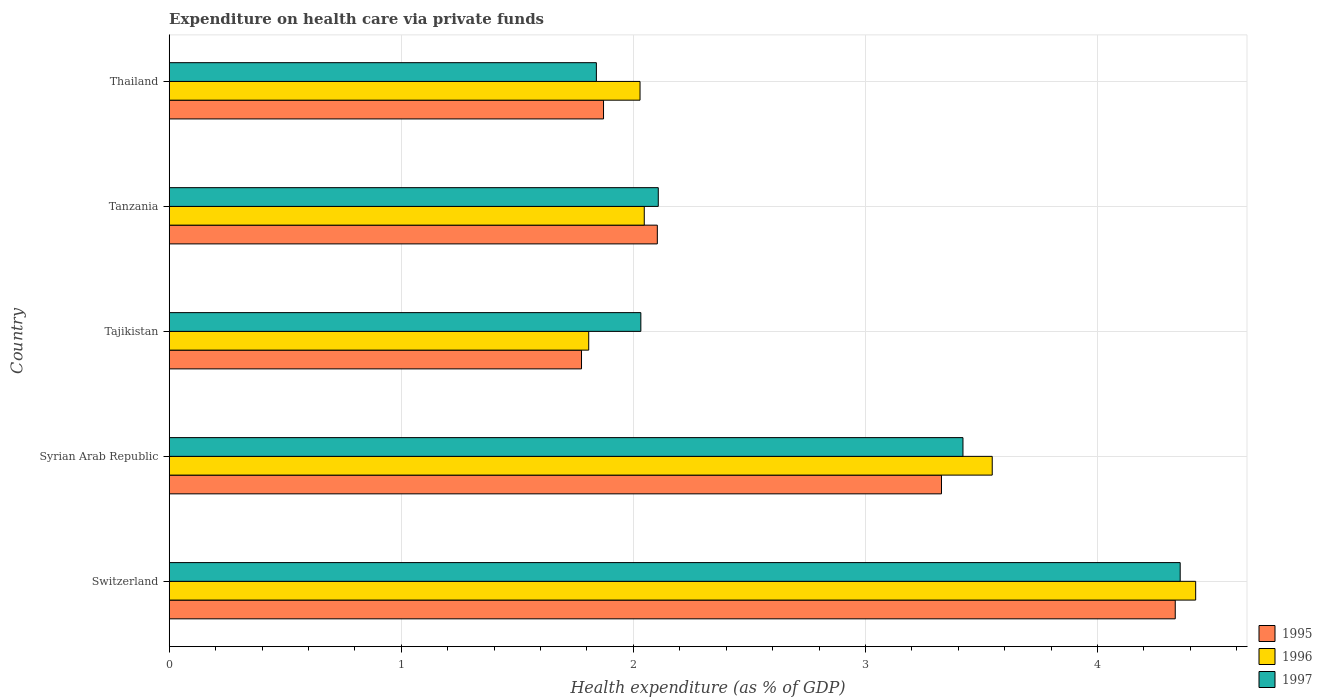How many different coloured bars are there?
Your response must be concise. 3. How many groups of bars are there?
Your answer should be compact. 5. Are the number of bars per tick equal to the number of legend labels?
Provide a succinct answer. Yes. How many bars are there on the 1st tick from the bottom?
Your answer should be very brief. 3. What is the label of the 5th group of bars from the top?
Keep it short and to the point. Switzerland. In how many cases, is the number of bars for a given country not equal to the number of legend labels?
Your answer should be very brief. 0. What is the expenditure made on health care in 1997 in Tanzania?
Make the answer very short. 2.11. Across all countries, what is the maximum expenditure made on health care in 1995?
Your answer should be compact. 4.33. Across all countries, what is the minimum expenditure made on health care in 1995?
Keep it short and to the point. 1.78. In which country was the expenditure made on health care in 1996 maximum?
Ensure brevity in your answer.  Switzerland. In which country was the expenditure made on health care in 1996 minimum?
Provide a short and direct response. Tajikistan. What is the total expenditure made on health care in 1995 in the graph?
Provide a succinct answer. 13.41. What is the difference between the expenditure made on health care in 1996 in Tajikistan and that in Tanzania?
Offer a very short reply. -0.24. What is the difference between the expenditure made on health care in 1995 in Syrian Arab Republic and the expenditure made on health care in 1997 in Tajikistan?
Ensure brevity in your answer.  1.3. What is the average expenditure made on health care in 1996 per country?
Give a very brief answer. 2.77. What is the difference between the expenditure made on health care in 1995 and expenditure made on health care in 1996 in Switzerland?
Your answer should be compact. -0.09. In how many countries, is the expenditure made on health care in 1997 greater than 4.4 %?
Your response must be concise. 0. What is the ratio of the expenditure made on health care in 1996 in Switzerland to that in Thailand?
Offer a terse response. 2.18. What is the difference between the highest and the second highest expenditure made on health care in 1997?
Ensure brevity in your answer.  0.94. What is the difference between the highest and the lowest expenditure made on health care in 1995?
Keep it short and to the point. 2.56. Is it the case that in every country, the sum of the expenditure made on health care in 1995 and expenditure made on health care in 1997 is greater than the expenditure made on health care in 1996?
Your answer should be compact. Yes. What is the difference between two consecutive major ticks on the X-axis?
Make the answer very short. 1. Are the values on the major ticks of X-axis written in scientific E-notation?
Ensure brevity in your answer.  No. How many legend labels are there?
Provide a succinct answer. 3. How are the legend labels stacked?
Provide a succinct answer. Vertical. What is the title of the graph?
Offer a terse response. Expenditure on health care via private funds. Does "2003" appear as one of the legend labels in the graph?
Give a very brief answer. No. What is the label or title of the X-axis?
Your response must be concise. Health expenditure (as % of GDP). What is the label or title of the Y-axis?
Provide a short and direct response. Country. What is the Health expenditure (as % of GDP) of 1995 in Switzerland?
Keep it short and to the point. 4.33. What is the Health expenditure (as % of GDP) in 1996 in Switzerland?
Provide a succinct answer. 4.42. What is the Health expenditure (as % of GDP) of 1997 in Switzerland?
Your response must be concise. 4.36. What is the Health expenditure (as % of GDP) of 1995 in Syrian Arab Republic?
Your answer should be compact. 3.33. What is the Health expenditure (as % of GDP) in 1996 in Syrian Arab Republic?
Make the answer very short. 3.55. What is the Health expenditure (as % of GDP) of 1997 in Syrian Arab Republic?
Offer a very short reply. 3.42. What is the Health expenditure (as % of GDP) in 1995 in Tajikistan?
Give a very brief answer. 1.78. What is the Health expenditure (as % of GDP) of 1996 in Tajikistan?
Your response must be concise. 1.81. What is the Health expenditure (as % of GDP) in 1997 in Tajikistan?
Provide a succinct answer. 2.03. What is the Health expenditure (as % of GDP) in 1995 in Tanzania?
Your answer should be compact. 2.1. What is the Health expenditure (as % of GDP) in 1996 in Tanzania?
Your response must be concise. 2.05. What is the Health expenditure (as % of GDP) in 1997 in Tanzania?
Make the answer very short. 2.11. What is the Health expenditure (as % of GDP) of 1995 in Thailand?
Give a very brief answer. 1.87. What is the Health expenditure (as % of GDP) of 1996 in Thailand?
Offer a very short reply. 2.03. What is the Health expenditure (as % of GDP) in 1997 in Thailand?
Your answer should be compact. 1.84. Across all countries, what is the maximum Health expenditure (as % of GDP) of 1995?
Provide a succinct answer. 4.33. Across all countries, what is the maximum Health expenditure (as % of GDP) of 1996?
Offer a terse response. 4.42. Across all countries, what is the maximum Health expenditure (as % of GDP) in 1997?
Your answer should be very brief. 4.36. Across all countries, what is the minimum Health expenditure (as % of GDP) of 1995?
Provide a short and direct response. 1.78. Across all countries, what is the minimum Health expenditure (as % of GDP) of 1996?
Keep it short and to the point. 1.81. Across all countries, what is the minimum Health expenditure (as % of GDP) in 1997?
Provide a succinct answer. 1.84. What is the total Health expenditure (as % of GDP) in 1995 in the graph?
Your answer should be compact. 13.41. What is the total Health expenditure (as % of GDP) in 1996 in the graph?
Offer a very short reply. 13.85. What is the total Health expenditure (as % of GDP) in 1997 in the graph?
Offer a very short reply. 13.76. What is the difference between the Health expenditure (as % of GDP) in 1996 in Switzerland and that in Syrian Arab Republic?
Keep it short and to the point. 0.88. What is the difference between the Health expenditure (as % of GDP) in 1997 in Switzerland and that in Syrian Arab Republic?
Offer a terse response. 0.94. What is the difference between the Health expenditure (as % of GDP) in 1995 in Switzerland and that in Tajikistan?
Keep it short and to the point. 2.56. What is the difference between the Health expenditure (as % of GDP) of 1996 in Switzerland and that in Tajikistan?
Provide a succinct answer. 2.62. What is the difference between the Health expenditure (as % of GDP) in 1997 in Switzerland and that in Tajikistan?
Your answer should be compact. 2.32. What is the difference between the Health expenditure (as % of GDP) in 1995 in Switzerland and that in Tanzania?
Your answer should be compact. 2.23. What is the difference between the Health expenditure (as % of GDP) in 1996 in Switzerland and that in Tanzania?
Give a very brief answer. 2.38. What is the difference between the Health expenditure (as % of GDP) in 1997 in Switzerland and that in Tanzania?
Offer a terse response. 2.25. What is the difference between the Health expenditure (as % of GDP) in 1995 in Switzerland and that in Thailand?
Ensure brevity in your answer.  2.46. What is the difference between the Health expenditure (as % of GDP) of 1996 in Switzerland and that in Thailand?
Make the answer very short. 2.39. What is the difference between the Health expenditure (as % of GDP) in 1997 in Switzerland and that in Thailand?
Your response must be concise. 2.52. What is the difference between the Health expenditure (as % of GDP) of 1995 in Syrian Arab Republic and that in Tajikistan?
Offer a very short reply. 1.55. What is the difference between the Health expenditure (as % of GDP) in 1996 in Syrian Arab Republic and that in Tajikistan?
Your response must be concise. 1.74. What is the difference between the Health expenditure (as % of GDP) of 1997 in Syrian Arab Republic and that in Tajikistan?
Make the answer very short. 1.39. What is the difference between the Health expenditure (as % of GDP) in 1995 in Syrian Arab Republic and that in Tanzania?
Your answer should be compact. 1.22. What is the difference between the Health expenditure (as % of GDP) of 1996 in Syrian Arab Republic and that in Tanzania?
Your response must be concise. 1.5. What is the difference between the Health expenditure (as % of GDP) in 1997 in Syrian Arab Republic and that in Tanzania?
Provide a succinct answer. 1.31. What is the difference between the Health expenditure (as % of GDP) of 1995 in Syrian Arab Republic and that in Thailand?
Keep it short and to the point. 1.46. What is the difference between the Health expenditure (as % of GDP) in 1996 in Syrian Arab Republic and that in Thailand?
Provide a short and direct response. 1.52. What is the difference between the Health expenditure (as % of GDP) in 1997 in Syrian Arab Republic and that in Thailand?
Provide a succinct answer. 1.58. What is the difference between the Health expenditure (as % of GDP) of 1995 in Tajikistan and that in Tanzania?
Offer a terse response. -0.33. What is the difference between the Health expenditure (as % of GDP) of 1996 in Tajikistan and that in Tanzania?
Provide a succinct answer. -0.24. What is the difference between the Health expenditure (as % of GDP) of 1997 in Tajikistan and that in Tanzania?
Offer a very short reply. -0.08. What is the difference between the Health expenditure (as % of GDP) in 1995 in Tajikistan and that in Thailand?
Give a very brief answer. -0.09. What is the difference between the Health expenditure (as % of GDP) in 1996 in Tajikistan and that in Thailand?
Give a very brief answer. -0.22. What is the difference between the Health expenditure (as % of GDP) in 1997 in Tajikistan and that in Thailand?
Make the answer very short. 0.19. What is the difference between the Health expenditure (as % of GDP) in 1995 in Tanzania and that in Thailand?
Ensure brevity in your answer.  0.23. What is the difference between the Health expenditure (as % of GDP) of 1996 in Tanzania and that in Thailand?
Give a very brief answer. 0.02. What is the difference between the Health expenditure (as % of GDP) of 1997 in Tanzania and that in Thailand?
Provide a short and direct response. 0.27. What is the difference between the Health expenditure (as % of GDP) in 1995 in Switzerland and the Health expenditure (as % of GDP) in 1996 in Syrian Arab Republic?
Provide a short and direct response. 0.79. What is the difference between the Health expenditure (as % of GDP) in 1995 in Switzerland and the Health expenditure (as % of GDP) in 1997 in Syrian Arab Republic?
Your response must be concise. 0.91. What is the difference between the Health expenditure (as % of GDP) in 1996 in Switzerland and the Health expenditure (as % of GDP) in 1997 in Syrian Arab Republic?
Your response must be concise. 1. What is the difference between the Health expenditure (as % of GDP) of 1995 in Switzerland and the Health expenditure (as % of GDP) of 1996 in Tajikistan?
Offer a very short reply. 2.53. What is the difference between the Health expenditure (as % of GDP) in 1995 in Switzerland and the Health expenditure (as % of GDP) in 1997 in Tajikistan?
Provide a succinct answer. 2.3. What is the difference between the Health expenditure (as % of GDP) of 1996 in Switzerland and the Health expenditure (as % of GDP) of 1997 in Tajikistan?
Your answer should be very brief. 2.39. What is the difference between the Health expenditure (as % of GDP) in 1995 in Switzerland and the Health expenditure (as % of GDP) in 1996 in Tanzania?
Make the answer very short. 2.29. What is the difference between the Health expenditure (as % of GDP) of 1995 in Switzerland and the Health expenditure (as % of GDP) of 1997 in Tanzania?
Give a very brief answer. 2.23. What is the difference between the Health expenditure (as % of GDP) in 1996 in Switzerland and the Health expenditure (as % of GDP) in 1997 in Tanzania?
Provide a short and direct response. 2.32. What is the difference between the Health expenditure (as % of GDP) in 1995 in Switzerland and the Health expenditure (as % of GDP) in 1996 in Thailand?
Keep it short and to the point. 2.31. What is the difference between the Health expenditure (as % of GDP) in 1995 in Switzerland and the Health expenditure (as % of GDP) in 1997 in Thailand?
Your answer should be compact. 2.49. What is the difference between the Health expenditure (as % of GDP) in 1996 in Switzerland and the Health expenditure (as % of GDP) in 1997 in Thailand?
Offer a terse response. 2.58. What is the difference between the Health expenditure (as % of GDP) in 1995 in Syrian Arab Republic and the Health expenditure (as % of GDP) in 1996 in Tajikistan?
Give a very brief answer. 1.52. What is the difference between the Health expenditure (as % of GDP) of 1995 in Syrian Arab Republic and the Health expenditure (as % of GDP) of 1997 in Tajikistan?
Make the answer very short. 1.3. What is the difference between the Health expenditure (as % of GDP) of 1996 in Syrian Arab Republic and the Health expenditure (as % of GDP) of 1997 in Tajikistan?
Offer a very short reply. 1.51. What is the difference between the Health expenditure (as % of GDP) of 1995 in Syrian Arab Republic and the Health expenditure (as % of GDP) of 1996 in Tanzania?
Provide a short and direct response. 1.28. What is the difference between the Health expenditure (as % of GDP) of 1995 in Syrian Arab Republic and the Health expenditure (as % of GDP) of 1997 in Tanzania?
Make the answer very short. 1.22. What is the difference between the Health expenditure (as % of GDP) in 1996 in Syrian Arab Republic and the Health expenditure (as % of GDP) in 1997 in Tanzania?
Your answer should be compact. 1.44. What is the difference between the Health expenditure (as % of GDP) in 1995 in Syrian Arab Republic and the Health expenditure (as % of GDP) in 1996 in Thailand?
Offer a very short reply. 1.3. What is the difference between the Health expenditure (as % of GDP) in 1995 in Syrian Arab Republic and the Health expenditure (as % of GDP) in 1997 in Thailand?
Your answer should be very brief. 1.49. What is the difference between the Health expenditure (as % of GDP) in 1996 in Syrian Arab Republic and the Health expenditure (as % of GDP) in 1997 in Thailand?
Give a very brief answer. 1.71. What is the difference between the Health expenditure (as % of GDP) in 1995 in Tajikistan and the Health expenditure (as % of GDP) in 1996 in Tanzania?
Give a very brief answer. -0.27. What is the difference between the Health expenditure (as % of GDP) of 1995 in Tajikistan and the Health expenditure (as % of GDP) of 1997 in Tanzania?
Your response must be concise. -0.33. What is the difference between the Health expenditure (as % of GDP) of 1996 in Tajikistan and the Health expenditure (as % of GDP) of 1997 in Tanzania?
Ensure brevity in your answer.  -0.3. What is the difference between the Health expenditure (as % of GDP) of 1995 in Tajikistan and the Health expenditure (as % of GDP) of 1996 in Thailand?
Offer a very short reply. -0.25. What is the difference between the Health expenditure (as % of GDP) of 1995 in Tajikistan and the Health expenditure (as % of GDP) of 1997 in Thailand?
Your answer should be very brief. -0.06. What is the difference between the Health expenditure (as % of GDP) of 1996 in Tajikistan and the Health expenditure (as % of GDP) of 1997 in Thailand?
Offer a very short reply. -0.03. What is the difference between the Health expenditure (as % of GDP) of 1995 in Tanzania and the Health expenditure (as % of GDP) of 1996 in Thailand?
Offer a very short reply. 0.07. What is the difference between the Health expenditure (as % of GDP) in 1995 in Tanzania and the Health expenditure (as % of GDP) in 1997 in Thailand?
Make the answer very short. 0.26. What is the difference between the Health expenditure (as % of GDP) in 1996 in Tanzania and the Health expenditure (as % of GDP) in 1997 in Thailand?
Offer a terse response. 0.21. What is the average Health expenditure (as % of GDP) in 1995 per country?
Your answer should be compact. 2.68. What is the average Health expenditure (as % of GDP) in 1996 per country?
Give a very brief answer. 2.77. What is the average Health expenditure (as % of GDP) of 1997 per country?
Ensure brevity in your answer.  2.75. What is the difference between the Health expenditure (as % of GDP) of 1995 and Health expenditure (as % of GDP) of 1996 in Switzerland?
Keep it short and to the point. -0.09. What is the difference between the Health expenditure (as % of GDP) in 1995 and Health expenditure (as % of GDP) in 1997 in Switzerland?
Your answer should be compact. -0.02. What is the difference between the Health expenditure (as % of GDP) in 1996 and Health expenditure (as % of GDP) in 1997 in Switzerland?
Provide a succinct answer. 0.07. What is the difference between the Health expenditure (as % of GDP) of 1995 and Health expenditure (as % of GDP) of 1996 in Syrian Arab Republic?
Ensure brevity in your answer.  -0.22. What is the difference between the Health expenditure (as % of GDP) of 1995 and Health expenditure (as % of GDP) of 1997 in Syrian Arab Republic?
Provide a succinct answer. -0.09. What is the difference between the Health expenditure (as % of GDP) of 1996 and Health expenditure (as % of GDP) of 1997 in Syrian Arab Republic?
Your answer should be very brief. 0.13. What is the difference between the Health expenditure (as % of GDP) in 1995 and Health expenditure (as % of GDP) in 1996 in Tajikistan?
Make the answer very short. -0.03. What is the difference between the Health expenditure (as % of GDP) of 1995 and Health expenditure (as % of GDP) of 1997 in Tajikistan?
Make the answer very short. -0.26. What is the difference between the Health expenditure (as % of GDP) in 1996 and Health expenditure (as % of GDP) in 1997 in Tajikistan?
Your answer should be very brief. -0.22. What is the difference between the Health expenditure (as % of GDP) of 1995 and Health expenditure (as % of GDP) of 1996 in Tanzania?
Keep it short and to the point. 0.06. What is the difference between the Health expenditure (as % of GDP) in 1995 and Health expenditure (as % of GDP) in 1997 in Tanzania?
Provide a succinct answer. -0. What is the difference between the Health expenditure (as % of GDP) in 1996 and Health expenditure (as % of GDP) in 1997 in Tanzania?
Offer a very short reply. -0.06. What is the difference between the Health expenditure (as % of GDP) in 1995 and Health expenditure (as % of GDP) in 1996 in Thailand?
Your answer should be compact. -0.16. What is the difference between the Health expenditure (as % of GDP) in 1995 and Health expenditure (as % of GDP) in 1997 in Thailand?
Give a very brief answer. 0.03. What is the difference between the Health expenditure (as % of GDP) in 1996 and Health expenditure (as % of GDP) in 1997 in Thailand?
Offer a terse response. 0.19. What is the ratio of the Health expenditure (as % of GDP) of 1995 in Switzerland to that in Syrian Arab Republic?
Keep it short and to the point. 1.3. What is the ratio of the Health expenditure (as % of GDP) of 1996 in Switzerland to that in Syrian Arab Republic?
Offer a terse response. 1.25. What is the ratio of the Health expenditure (as % of GDP) in 1997 in Switzerland to that in Syrian Arab Republic?
Provide a succinct answer. 1.27. What is the ratio of the Health expenditure (as % of GDP) in 1995 in Switzerland to that in Tajikistan?
Provide a short and direct response. 2.44. What is the ratio of the Health expenditure (as % of GDP) in 1996 in Switzerland to that in Tajikistan?
Offer a very short reply. 2.45. What is the ratio of the Health expenditure (as % of GDP) of 1997 in Switzerland to that in Tajikistan?
Give a very brief answer. 2.14. What is the ratio of the Health expenditure (as % of GDP) in 1995 in Switzerland to that in Tanzania?
Give a very brief answer. 2.06. What is the ratio of the Health expenditure (as % of GDP) of 1996 in Switzerland to that in Tanzania?
Your answer should be compact. 2.16. What is the ratio of the Health expenditure (as % of GDP) in 1997 in Switzerland to that in Tanzania?
Provide a succinct answer. 2.07. What is the ratio of the Health expenditure (as % of GDP) of 1995 in Switzerland to that in Thailand?
Your answer should be very brief. 2.32. What is the ratio of the Health expenditure (as % of GDP) in 1996 in Switzerland to that in Thailand?
Ensure brevity in your answer.  2.18. What is the ratio of the Health expenditure (as % of GDP) in 1997 in Switzerland to that in Thailand?
Ensure brevity in your answer.  2.37. What is the ratio of the Health expenditure (as % of GDP) in 1995 in Syrian Arab Republic to that in Tajikistan?
Offer a terse response. 1.87. What is the ratio of the Health expenditure (as % of GDP) in 1996 in Syrian Arab Republic to that in Tajikistan?
Your answer should be very brief. 1.96. What is the ratio of the Health expenditure (as % of GDP) in 1997 in Syrian Arab Republic to that in Tajikistan?
Your response must be concise. 1.68. What is the ratio of the Health expenditure (as % of GDP) in 1995 in Syrian Arab Republic to that in Tanzania?
Provide a succinct answer. 1.58. What is the ratio of the Health expenditure (as % of GDP) of 1996 in Syrian Arab Republic to that in Tanzania?
Your answer should be very brief. 1.73. What is the ratio of the Health expenditure (as % of GDP) of 1997 in Syrian Arab Republic to that in Tanzania?
Offer a terse response. 1.62. What is the ratio of the Health expenditure (as % of GDP) in 1995 in Syrian Arab Republic to that in Thailand?
Give a very brief answer. 1.78. What is the ratio of the Health expenditure (as % of GDP) of 1996 in Syrian Arab Republic to that in Thailand?
Provide a succinct answer. 1.75. What is the ratio of the Health expenditure (as % of GDP) in 1997 in Syrian Arab Republic to that in Thailand?
Keep it short and to the point. 1.86. What is the ratio of the Health expenditure (as % of GDP) in 1995 in Tajikistan to that in Tanzania?
Your response must be concise. 0.84. What is the ratio of the Health expenditure (as % of GDP) in 1996 in Tajikistan to that in Tanzania?
Keep it short and to the point. 0.88. What is the ratio of the Health expenditure (as % of GDP) in 1997 in Tajikistan to that in Tanzania?
Make the answer very short. 0.96. What is the ratio of the Health expenditure (as % of GDP) of 1995 in Tajikistan to that in Thailand?
Provide a succinct answer. 0.95. What is the ratio of the Health expenditure (as % of GDP) in 1996 in Tajikistan to that in Thailand?
Provide a short and direct response. 0.89. What is the ratio of the Health expenditure (as % of GDP) in 1997 in Tajikistan to that in Thailand?
Make the answer very short. 1.1. What is the ratio of the Health expenditure (as % of GDP) of 1995 in Tanzania to that in Thailand?
Make the answer very short. 1.12. What is the ratio of the Health expenditure (as % of GDP) in 1997 in Tanzania to that in Thailand?
Your answer should be compact. 1.14. What is the difference between the highest and the second highest Health expenditure (as % of GDP) in 1996?
Provide a succinct answer. 0.88. What is the difference between the highest and the second highest Health expenditure (as % of GDP) of 1997?
Your answer should be compact. 0.94. What is the difference between the highest and the lowest Health expenditure (as % of GDP) in 1995?
Your response must be concise. 2.56. What is the difference between the highest and the lowest Health expenditure (as % of GDP) in 1996?
Offer a very short reply. 2.62. What is the difference between the highest and the lowest Health expenditure (as % of GDP) of 1997?
Offer a very short reply. 2.52. 